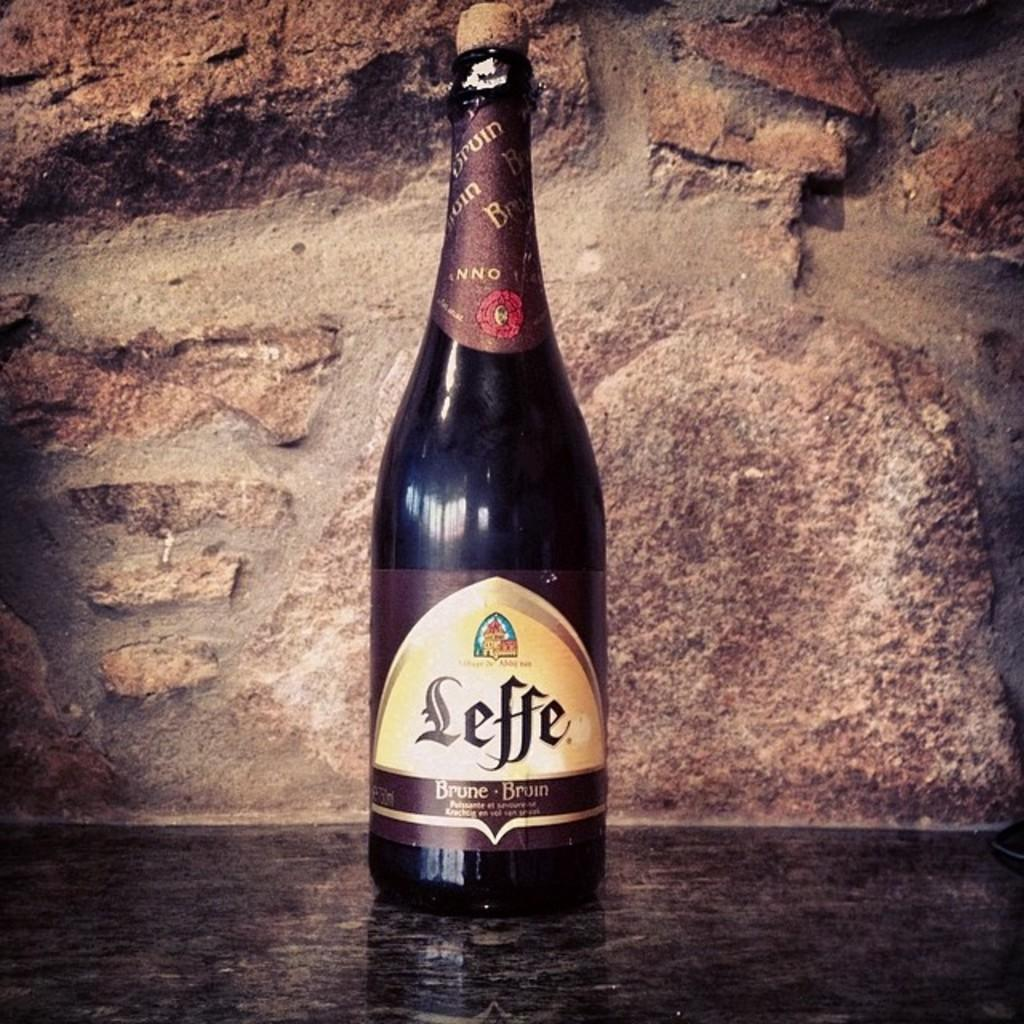Provide a one-sentence caption for the provided image. A Leffe Brune Bruin bottle of liquor is displayed in front of a brown wall background. 